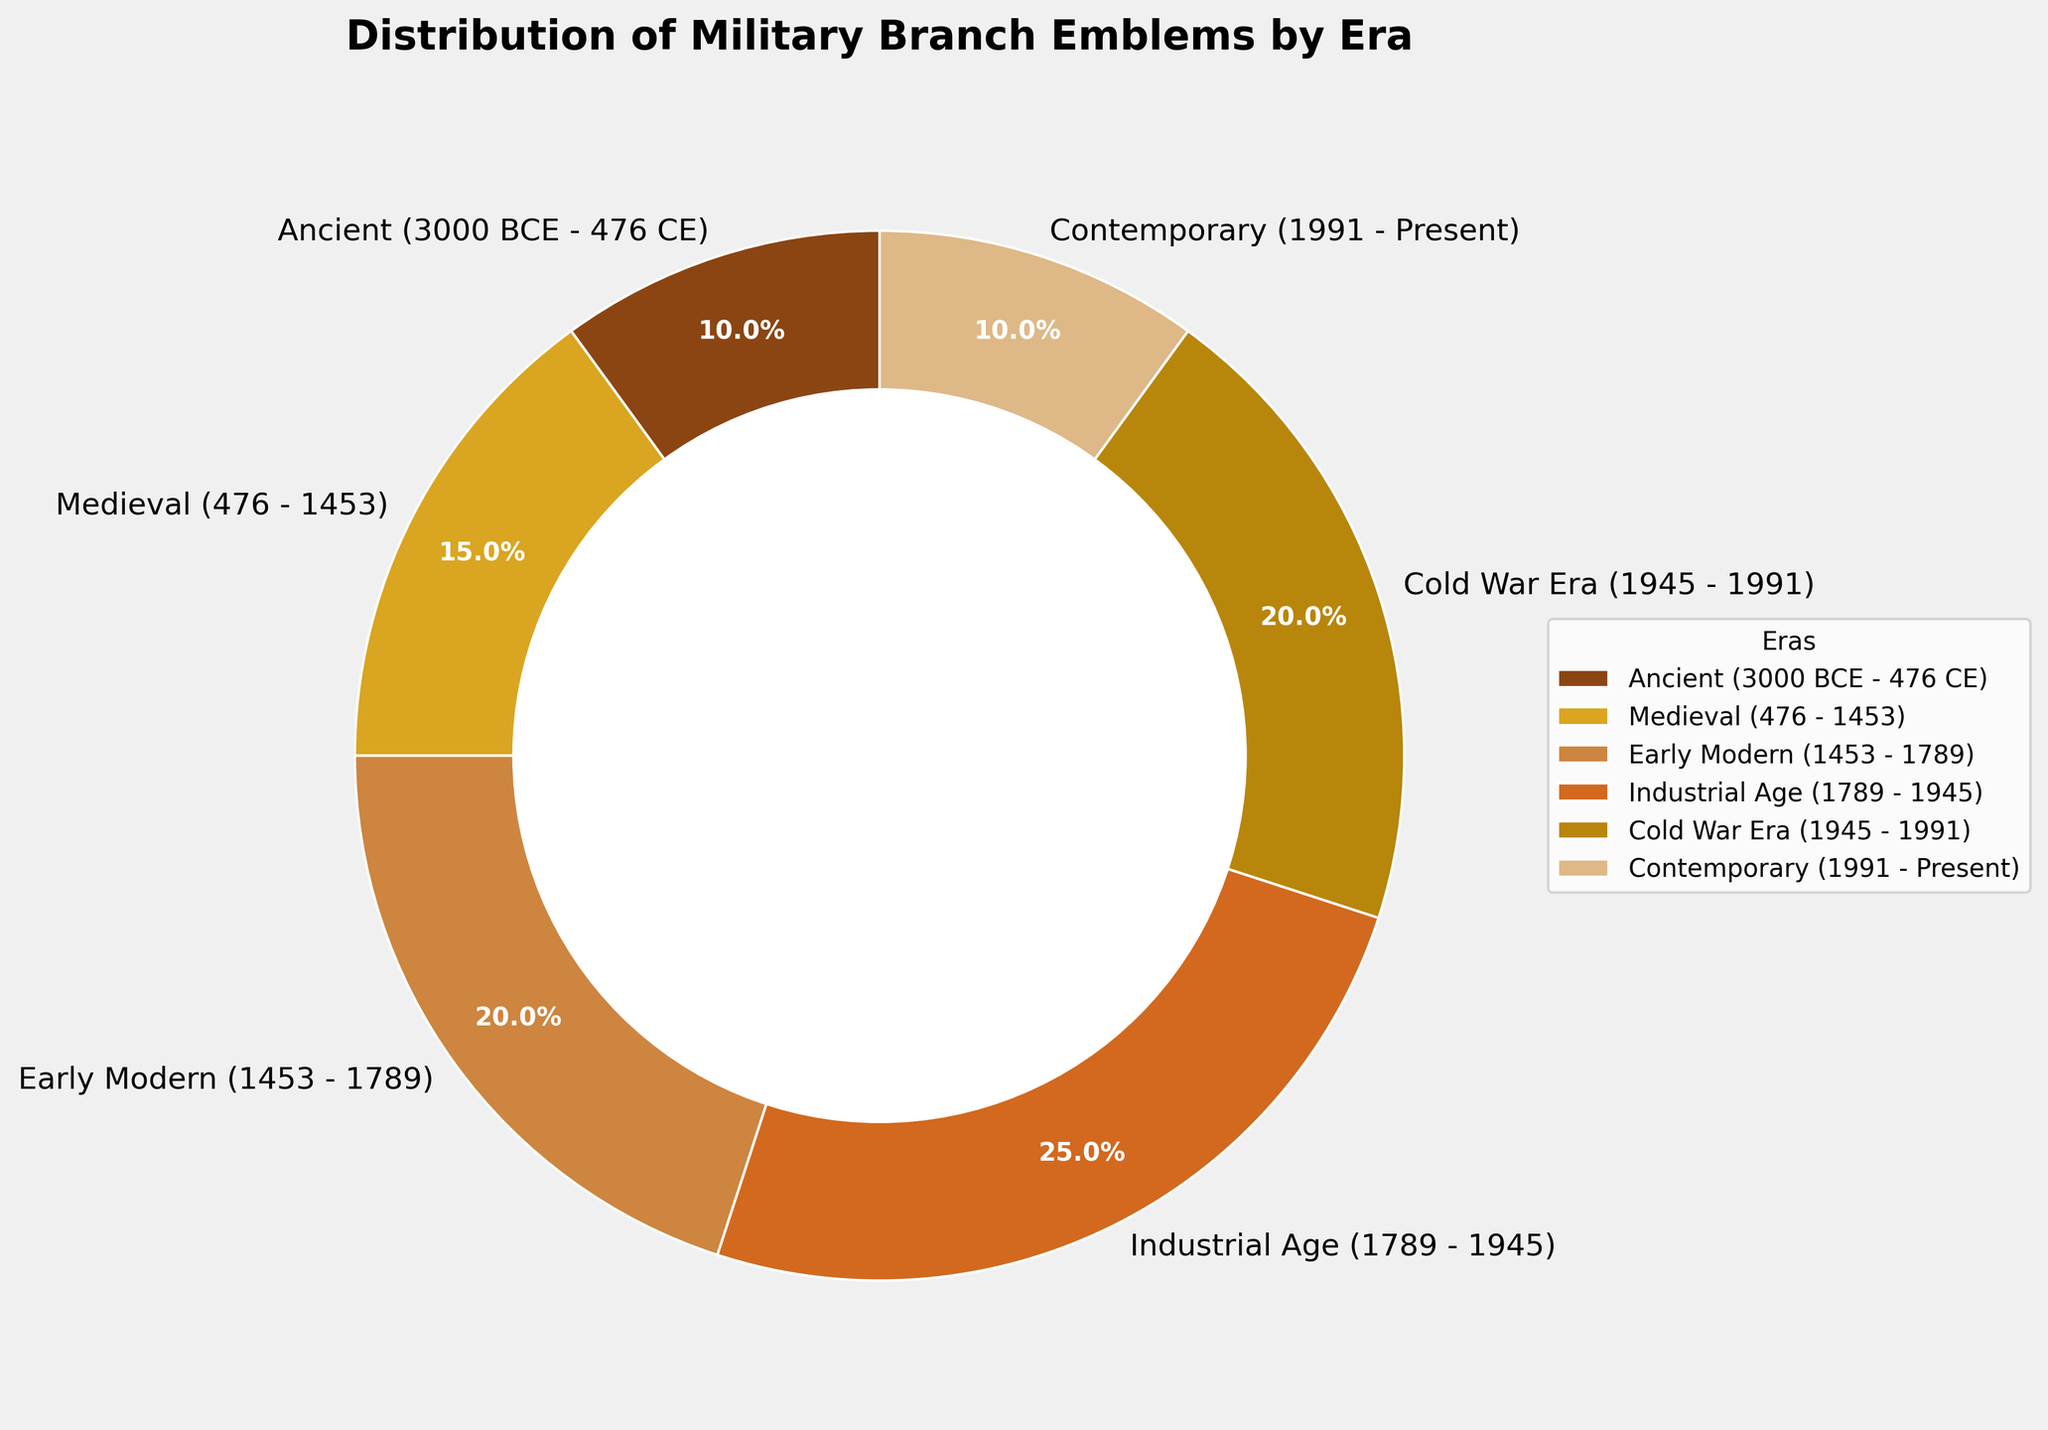What is the percentage of military branch emblems in the Medieval era? Look at the pie chart and locate the section labeled "Medieval (476 - 1453)." The percentage is written inside or near the slice.
Answer: 15% Which era has the largest share of military branch emblems? Find the largest slice of the pie chart and read the corresponding label.
Answer: Industrial Age (1789 - 1945) What is the combined percentage of military branch emblems from the Ancient and Contemporary eras? Locate the slices for "Ancient (3000 BCE - 476 CE)" and "Contemporary (1991 - Present)" and add their percentages together.
Answer: 10% + 10% = 20% How does the percentage of the Cold War Era compare to the Early Modern Era? Find the slices for "Cold War Era (1945 - 1991)" and "Early Modern (1453 - 1789)" and compare their sizes and percentages.
Answer: 20% is equal to 20% Which era between Industrial Age and Cold War Era has more military branch emblems? Locate the slices for both "Industrial Age (1789 - 1945)" and "Cold War Era (1945 - 1991)" and compare their percentages.
Answer: Industrial Age What fraction of the pie chart is represented by the Medieval and Early Modern eras combined? Locate the slices labeled "Medieval (476 - 1453)" and "Early Modern (1453 - 1789)" and add their percentages together. Then convert that sum into a fraction of 100%.
Answer: 15% + 20% = 35% Which eras are represented by brown shades in the pie chart? Identify the colors used in the pie chart; brown shades are used for several slices. Then, read the corresponding labels.
Answer: Ancient, Medieval, Early Modern, Industrial Age, Cold War Era, Contemporary How many eras have a percentage of exactly 10%? Scan the pie chart for slices labeled with 10% and count how many such sections there are.
Answer: 2 eras Compare the sum of percentages for the Modern (1453 - 1789) and Industrial Age (1789 - 1945) with that of the Cold War Era (1945 - 1991). Add the percentages for "Early Modern" and "Industrial Age" and compare it with the percentage of "Cold War Era."
Answer: 20% + 25% = 45%, which is greater than 20% Which era has a double share compared to the percentage of the Ancient era? Identify the era with twice the percentage of "Ancient (3000 BCE - 476 CE)," which is 10%. Look for a slice labeled 20%.
Answer: Early Modern 